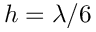<formula> <loc_0><loc_0><loc_500><loc_500>h = \lambda / 6</formula> 